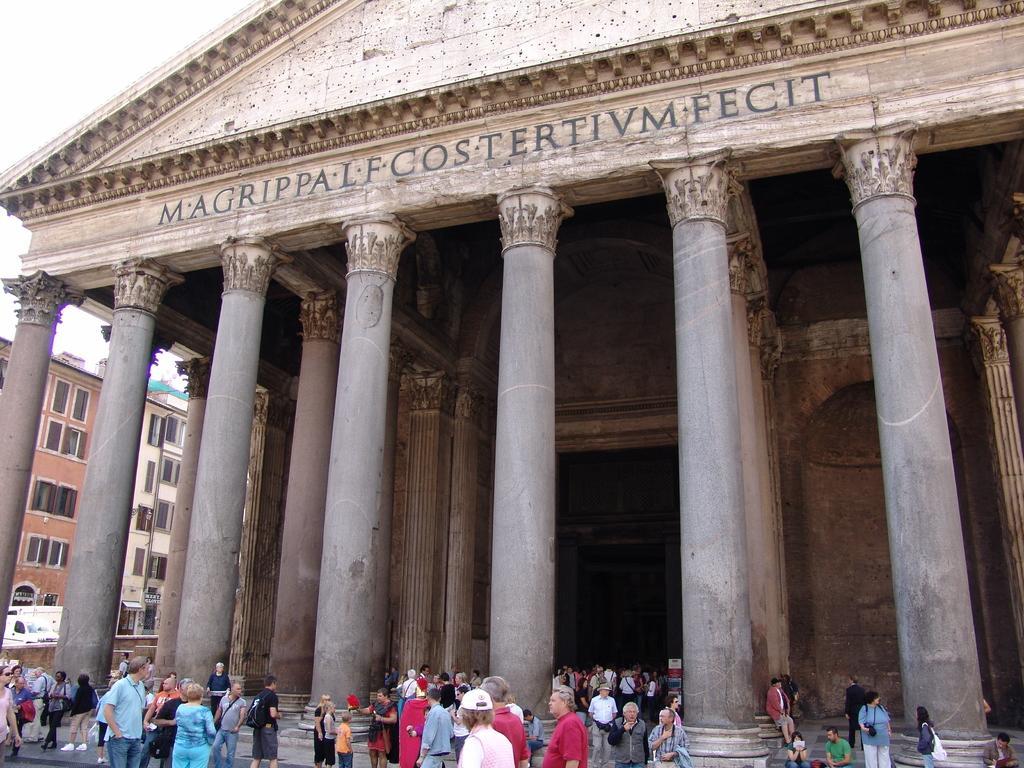Please provide a concise description of this image. As we can see in the image there are buildings, few people here and there, windows and sky. 